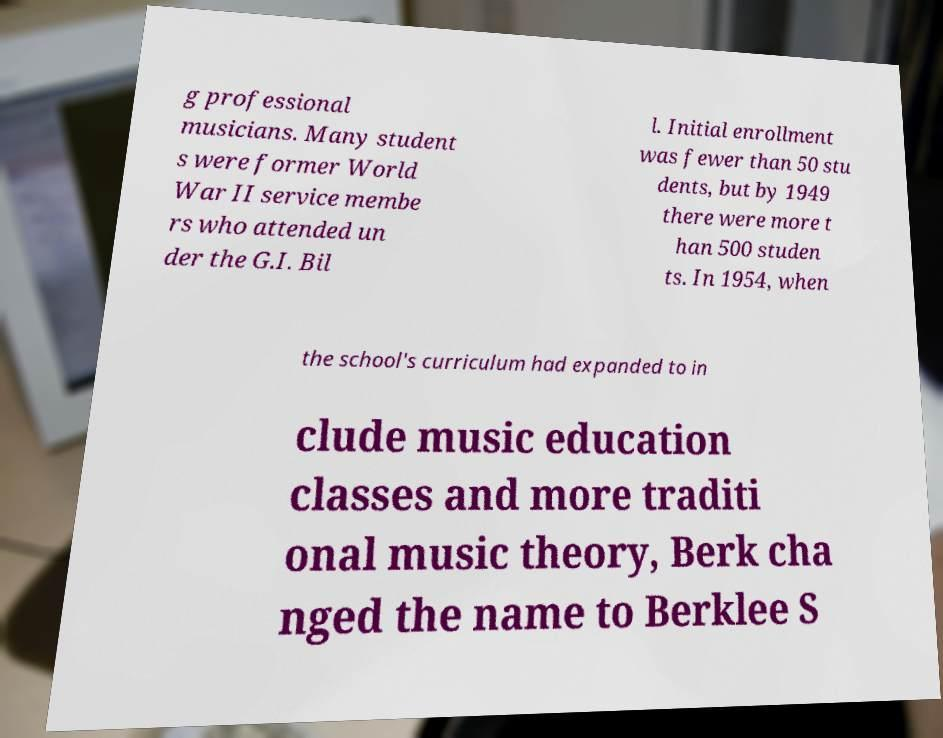I need the written content from this picture converted into text. Can you do that? g professional musicians. Many student s were former World War II service membe rs who attended un der the G.I. Bil l. Initial enrollment was fewer than 50 stu dents, but by 1949 there were more t han 500 studen ts. In 1954, when the school's curriculum had expanded to in clude music education classes and more traditi onal music theory, Berk cha nged the name to Berklee S 